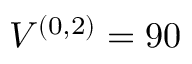Convert formula to latex. <formula><loc_0><loc_0><loc_500><loc_500>V ^ { ( 0 , 2 ) } = 9 0 \</formula> 